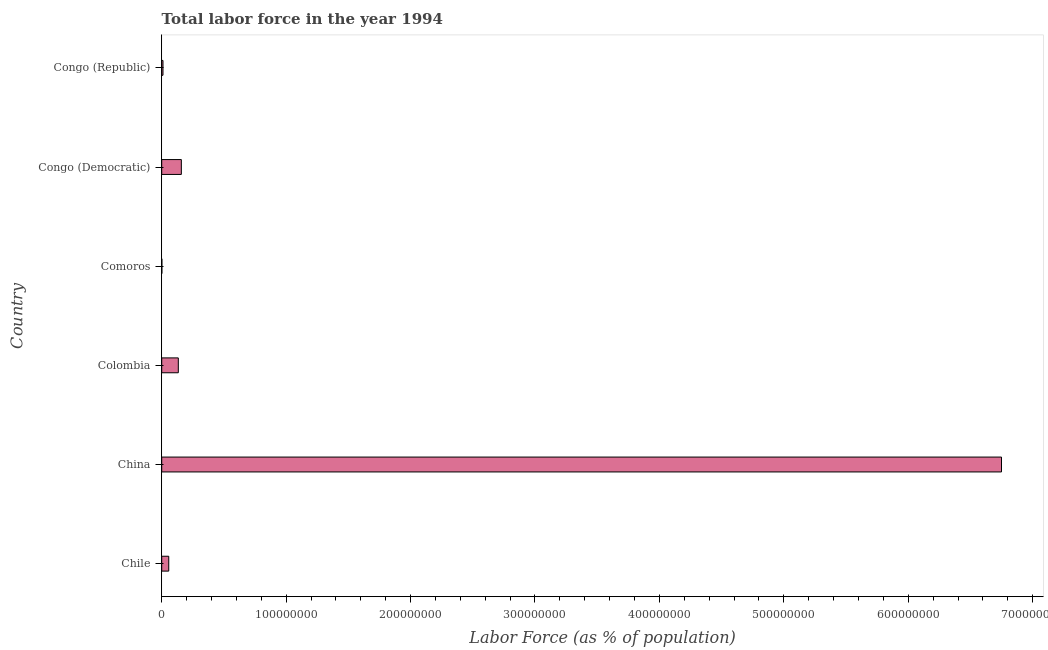What is the title of the graph?
Your answer should be very brief. Total labor force in the year 1994. What is the label or title of the X-axis?
Offer a very short reply. Labor Force (as % of population). What is the label or title of the Y-axis?
Offer a very short reply. Country. What is the total labor force in Comoros?
Offer a terse response. 1.37e+05. Across all countries, what is the maximum total labor force?
Your answer should be compact. 6.75e+08. Across all countries, what is the minimum total labor force?
Give a very brief answer. 1.37e+05. In which country was the total labor force maximum?
Your answer should be very brief. China. In which country was the total labor force minimum?
Give a very brief answer. Comoros. What is the sum of the total labor force?
Offer a terse response. 7.11e+08. What is the difference between the total labor force in China and Colombia?
Your answer should be compact. 6.62e+08. What is the average total labor force per country?
Keep it short and to the point. 1.18e+08. What is the median total labor force?
Offer a terse response. 9.50e+06. In how many countries, is the total labor force greater than 440000000 %?
Your response must be concise. 1. What is the ratio of the total labor force in Chile to that in China?
Ensure brevity in your answer.  0.01. Is the total labor force in China less than that in Congo (Republic)?
Your answer should be compact. No. Is the difference between the total labor force in Comoros and Congo (Republic) greater than the difference between any two countries?
Ensure brevity in your answer.  No. What is the difference between the highest and the second highest total labor force?
Ensure brevity in your answer.  6.59e+08. Is the sum of the total labor force in Chile and China greater than the maximum total labor force across all countries?
Offer a terse response. Yes. What is the difference between the highest and the lowest total labor force?
Offer a very short reply. 6.75e+08. How many bars are there?
Your answer should be compact. 6. Are all the bars in the graph horizontal?
Offer a terse response. Yes. How many countries are there in the graph?
Give a very brief answer. 6. What is the Labor Force (as % of population) of Chile?
Keep it short and to the point. 5.65e+06. What is the Labor Force (as % of population) in China?
Ensure brevity in your answer.  6.75e+08. What is the Labor Force (as % of population) of Colombia?
Provide a short and direct response. 1.33e+07. What is the Labor Force (as % of population) of Comoros?
Make the answer very short. 1.37e+05. What is the Labor Force (as % of population) in Congo (Democratic)?
Offer a terse response. 1.58e+07. What is the Labor Force (as % of population) of Congo (Republic)?
Make the answer very short. 1.02e+06. What is the difference between the Labor Force (as % of population) in Chile and China?
Offer a terse response. -6.69e+08. What is the difference between the Labor Force (as % of population) in Chile and Colombia?
Offer a terse response. -7.69e+06. What is the difference between the Labor Force (as % of population) in Chile and Comoros?
Your response must be concise. 5.52e+06. What is the difference between the Labor Force (as % of population) in Chile and Congo (Democratic)?
Offer a terse response. -1.01e+07. What is the difference between the Labor Force (as % of population) in Chile and Congo (Republic)?
Keep it short and to the point. 4.64e+06. What is the difference between the Labor Force (as % of population) in China and Colombia?
Keep it short and to the point. 6.62e+08. What is the difference between the Labor Force (as % of population) in China and Comoros?
Give a very brief answer. 6.75e+08. What is the difference between the Labor Force (as % of population) in China and Congo (Democratic)?
Make the answer very short. 6.59e+08. What is the difference between the Labor Force (as % of population) in China and Congo (Republic)?
Your answer should be very brief. 6.74e+08. What is the difference between the Labor Force (as % of population) in Colombia and Comoros?
Provide a short and direct response. 1.32e+07. What is the difference between the Labor Force (as % of population) in Colombia and Congo (Democratic)?
Your answer should be very brief. -2.44e+06. What is the difference between the Labor Force (as % of population) in Colombia and Congo (Republic)?
Your answer should be very brief. 1.23e+07. What is the difference between the Labor Force (as % of population) in Comoros and Congo (Democratic)?
Your response must be concise. -1.56e+07. What is the difference between the Labor Force (as % of population) in Comoros and Congo (Republic)?
Your answer should be compact. -8.82e+05. What is the difference between the Labor Force (as % of population) in Congo (Democratic) and Congo (Republic)?
Keep it short and to the point. 1.48e+07. What is the ratio of the Labor Force (as % of population) in Chile to that in China?
Make the answer very short. 0.01. What is the ratio of the Labor Force (as % of population) in Chile to that in Colombia?
Make the answer very short. 0.42. What is the ratio of the Labor Force (as % of population) in Chile to that in Comoros?
Provide a short and direct response. 41.41. What is the ratio of the Labor Force (as % of population) in Chile to that in Congo (Democratic)?
Keep it short and to the point. 0.36. What is the ratio of the Labor Force (as % of population) in Chile to that in Congo (Republic)?
Give a very brief answer. 5.55. What is the ratio of the Labor Force (as % of population) in China to that in Colombia?
Provide a short and direct response. 50.57. What is the ratio of the Labor Force (as % of population) in China to that in Comoros?
Keep it short and to the point. 4944.38. What is the ratio of the Labor Force (as % of population) in China to that in Congo (Democratic)?
Offer a very short reply. 42.76. What is the ratio of the Labor Force (as % of population) in China to that in Congo (Republic)?
Provide a succinct answer. 662.98. What is the ratio of the Labor Force (as % of population) in Colombia to that in Comoros?
Provide a succinct answer. 97.77. What is the ratio of the Labor Force (as % of population) in Colombia to that in Congo (Democratic)?
Your response must be concise. 0.85. What is the ratio of the Labor Force (as % of population) in Colombia to that in Congo (Republic)?
Make the answer very short. 13.11. What is the ratio of the Labor Force (as % of population) in Comoros to that in Congo (Democratic)?
Your answer should be very brief. 0.01. What is the ratio of the Labor Force (as % of population) in Comoros to that in Congo (Republic)?
Keep it short and to the point. 0.13. What is the ratio of the Labor Force (as % of population) in Congo (Democratic) to that in Congo (Republic)?
Offer a terse response. 15.5. 